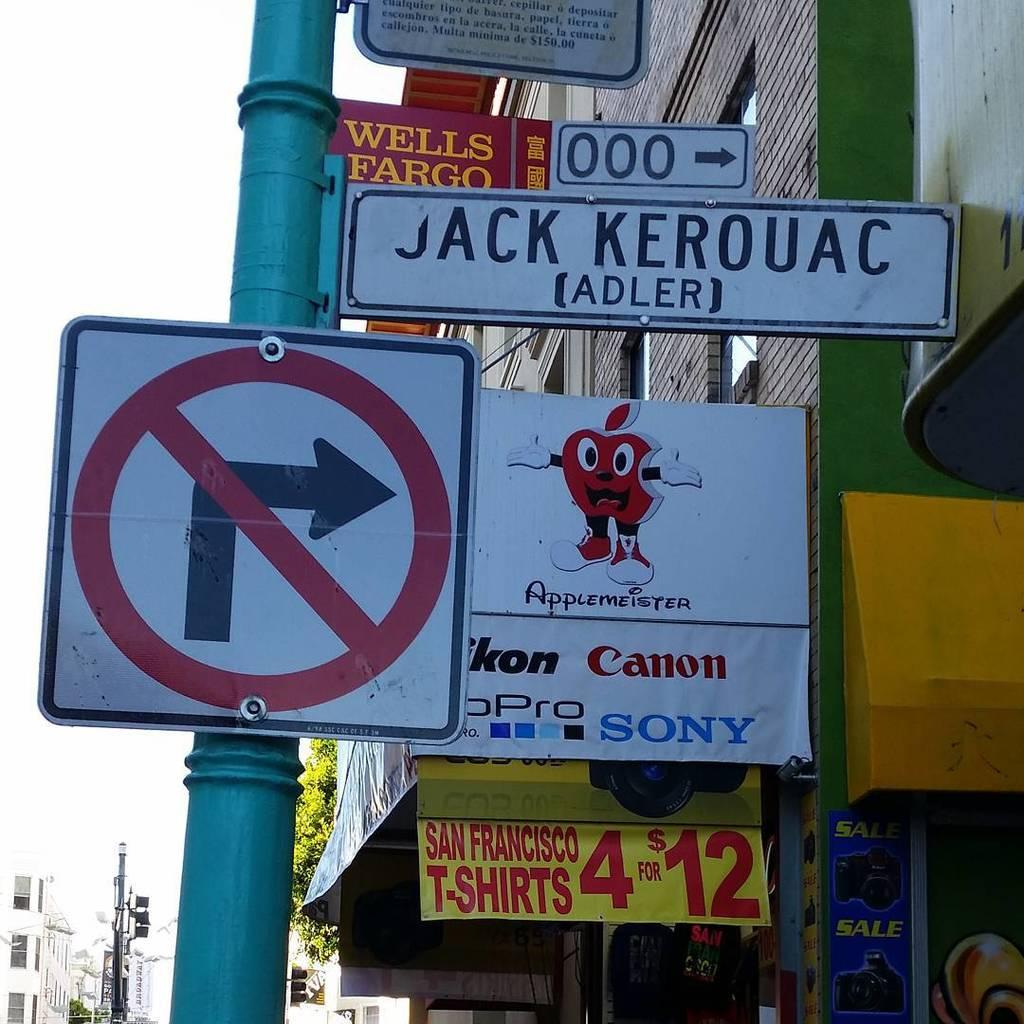Provide a one-sentence caption for the provided image. Several street signs with ads in the background for Canon and t-shirts. 